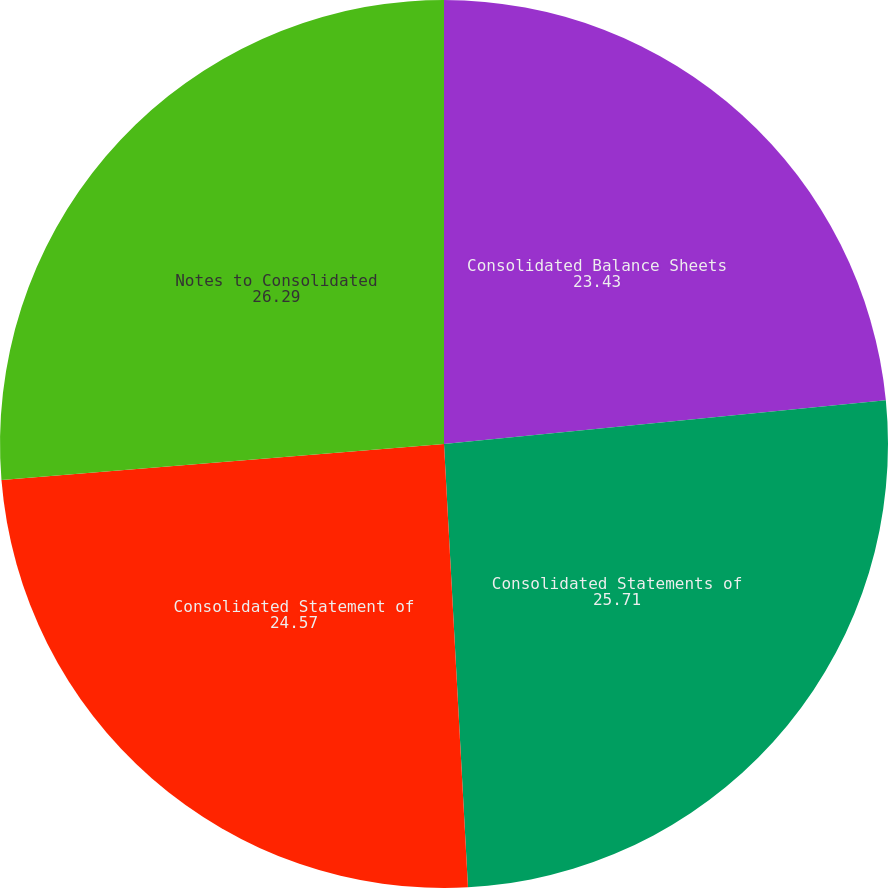Convert chart to OTSL. <chart><loc_0><loc_0><loc_500><loc_500><pie_chart><fcel>Consolidated Balance Sheets<fcel>Consolidated Statements of<fcel>Consolidated Statement of<fcel>Notes to Consolidated<nl><fcel>23.43%<fcel>25.71%<fcel>24.57%<fcel>26.29%<nl></chart> 